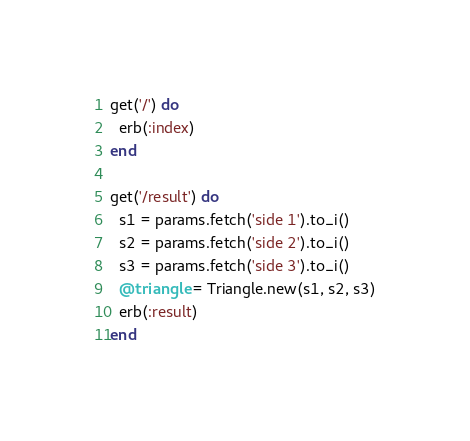Convert code to text. <code><loc_0><loc_0><loc_500><loc_500><_Ruby_>
get('/') do
  erb(:index)
end

get('/result') do
  s1 = params.fetch('side 1').to_i()
  s2 = params.fetch('side 2').to_i()
  s3 = params.fetch('side 3').to_i()
  @triangle = Triangle.new(s1, s2, s3)
  erb(:result)
end
</code> 